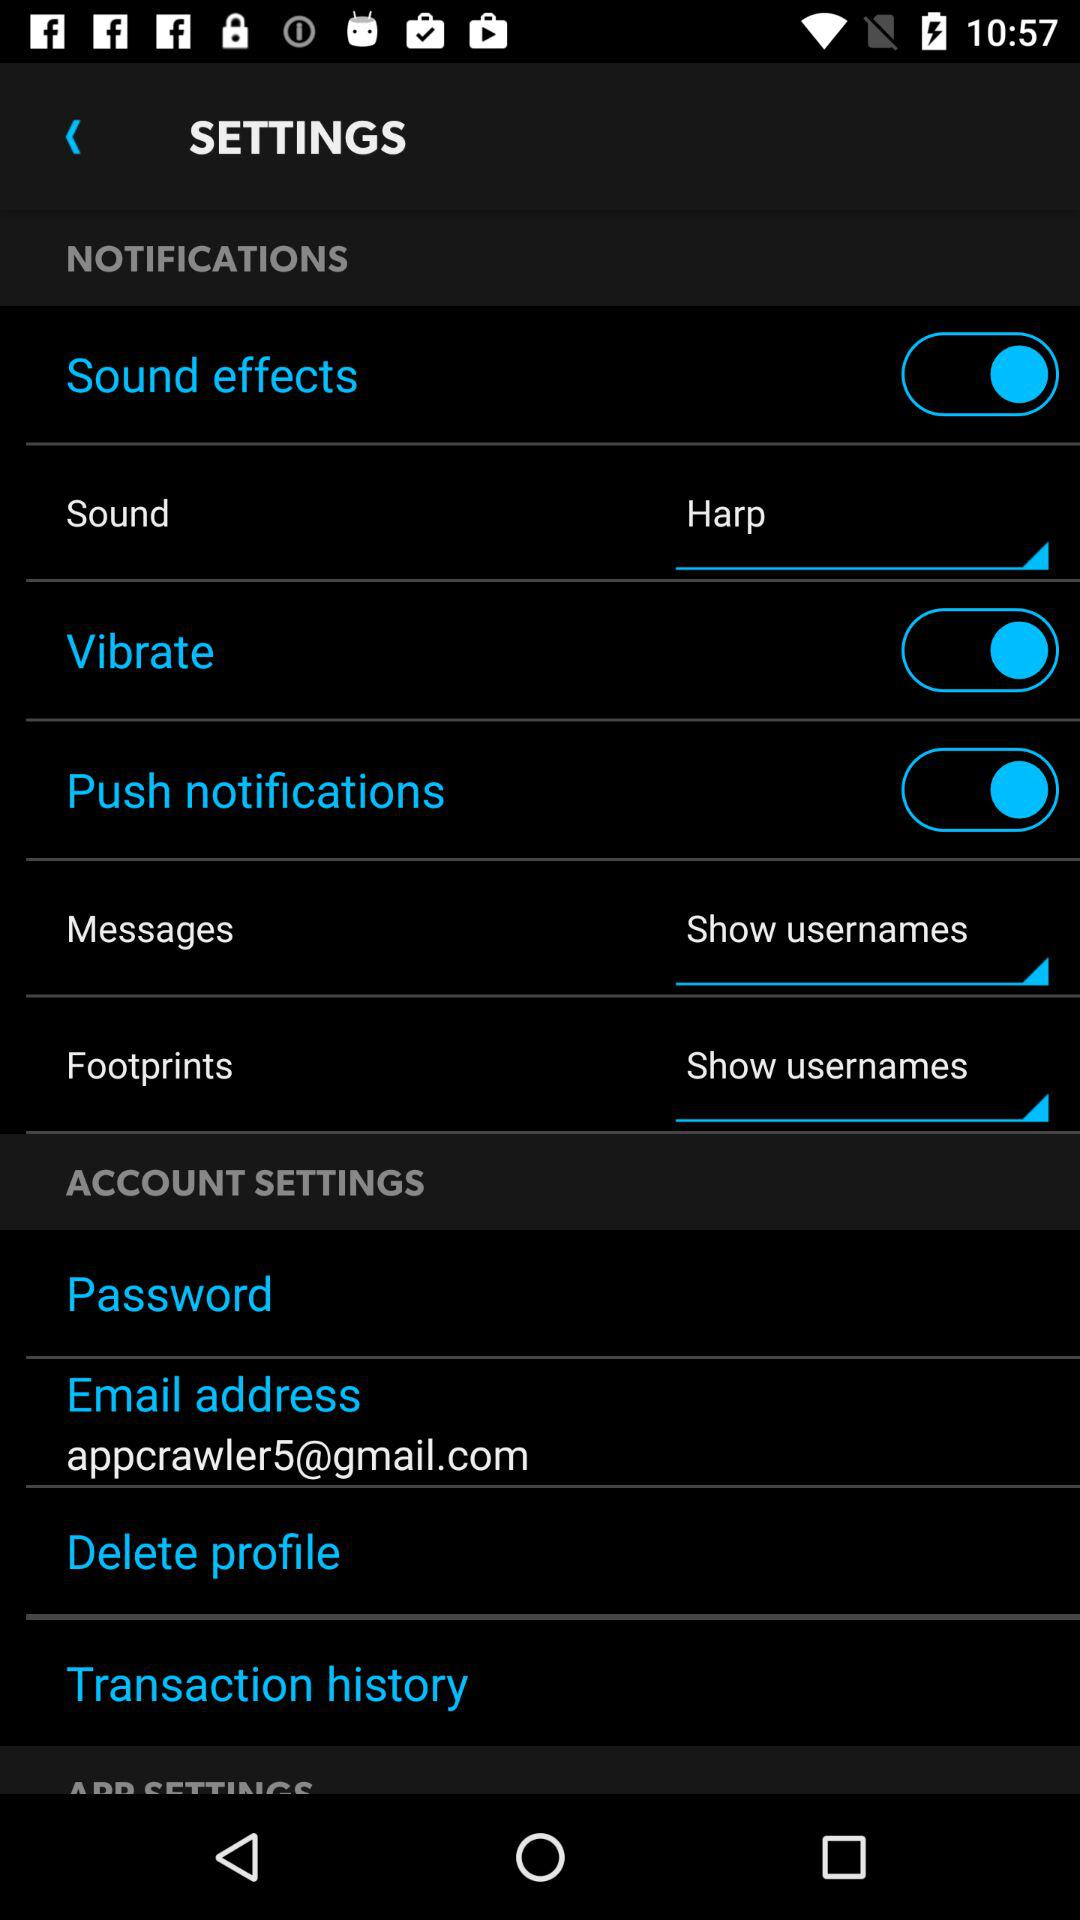What is the selected sound? The selected sound is "Harp". 